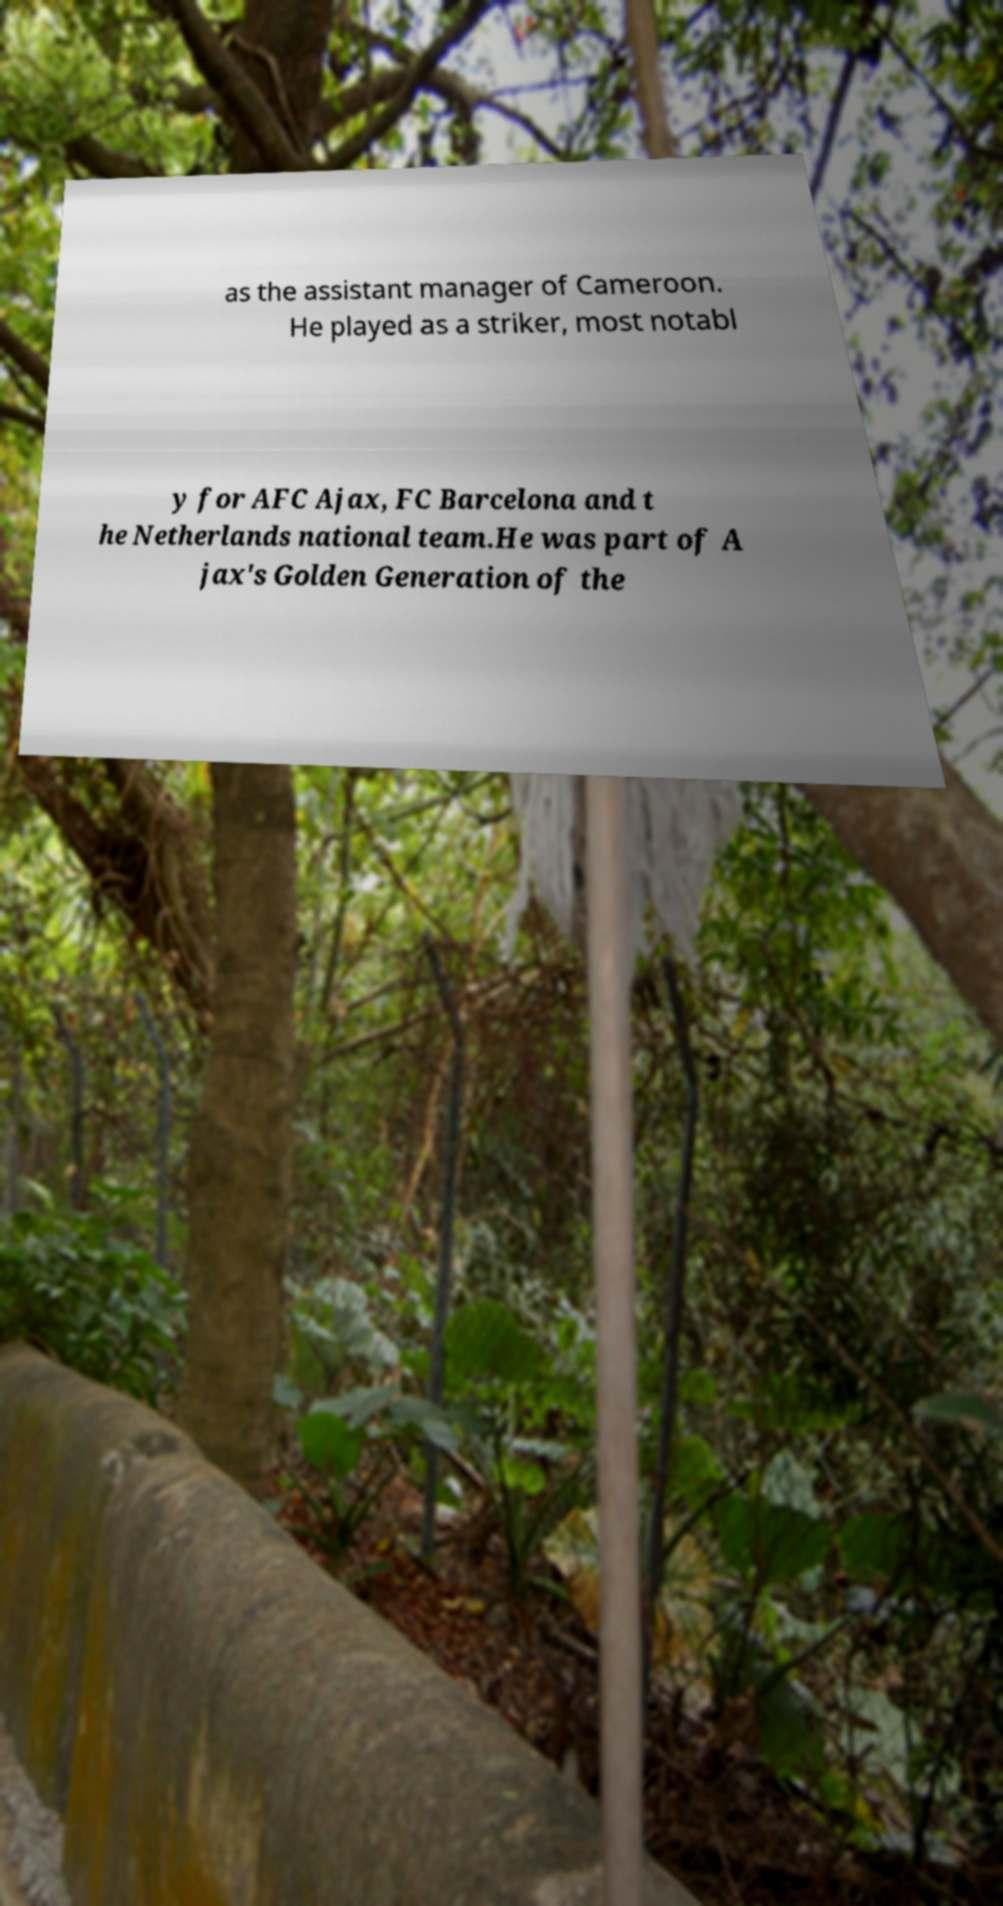For documentation purposes, I need the text within this image transcribed. Could you provide that? as the assistant manager of Cameroon. He played as a striker, most notabl y for AFC Ajax, FC Barcelona and t he Netherlands national team.He was part of A jax's Golden Generation of the 